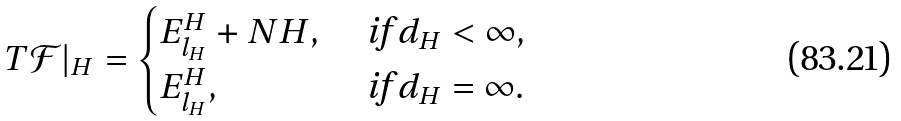Convert formula to latex. <formula><loc_0><loc_0><loc_500><loc_500>T { \mathcal { F } } | _ { H } = \begin{cases} E _ { l _ { H } } ^ { H } + N H , & \text { if } d _ { H } < \infty , \\ E _ { l _ { H } } ^ { H } , & \text { if } d _ { H } = \infty . \end{cases}</formula> 